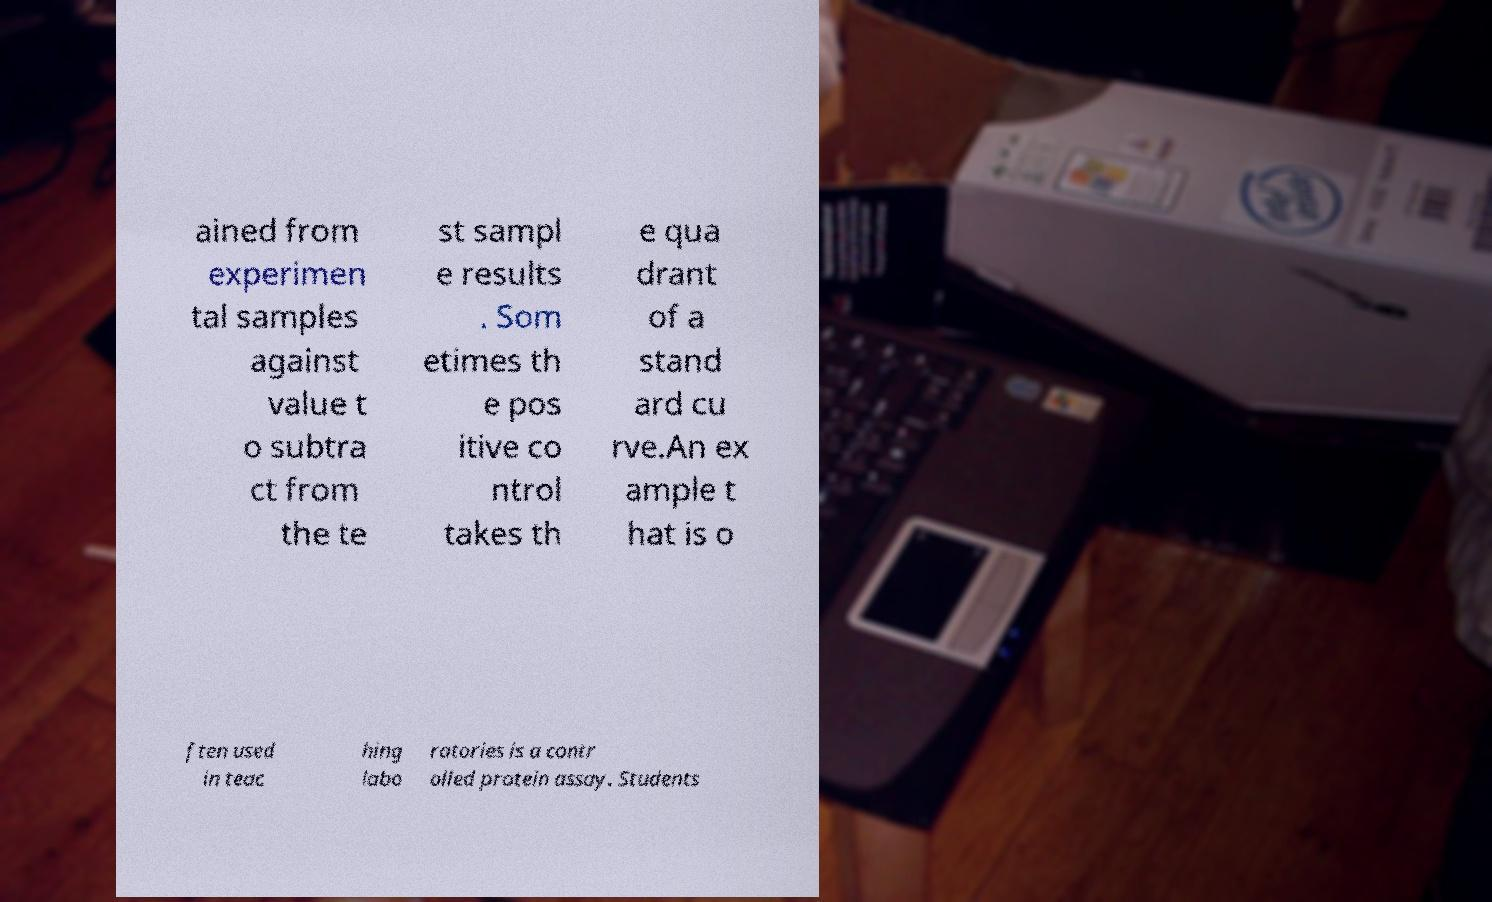What messages or text are displayed in this image? I need them in a readable, typed format. ained from experimen tal samples against value t o subtra ct from the te st sampl e results . Som etimes th e pos itive co ntrol takes th e qua drant of a stand ard cu rve.An ex ample t hat is o ften used in teac hing labo ratories is a contr olled protein assay. Students 